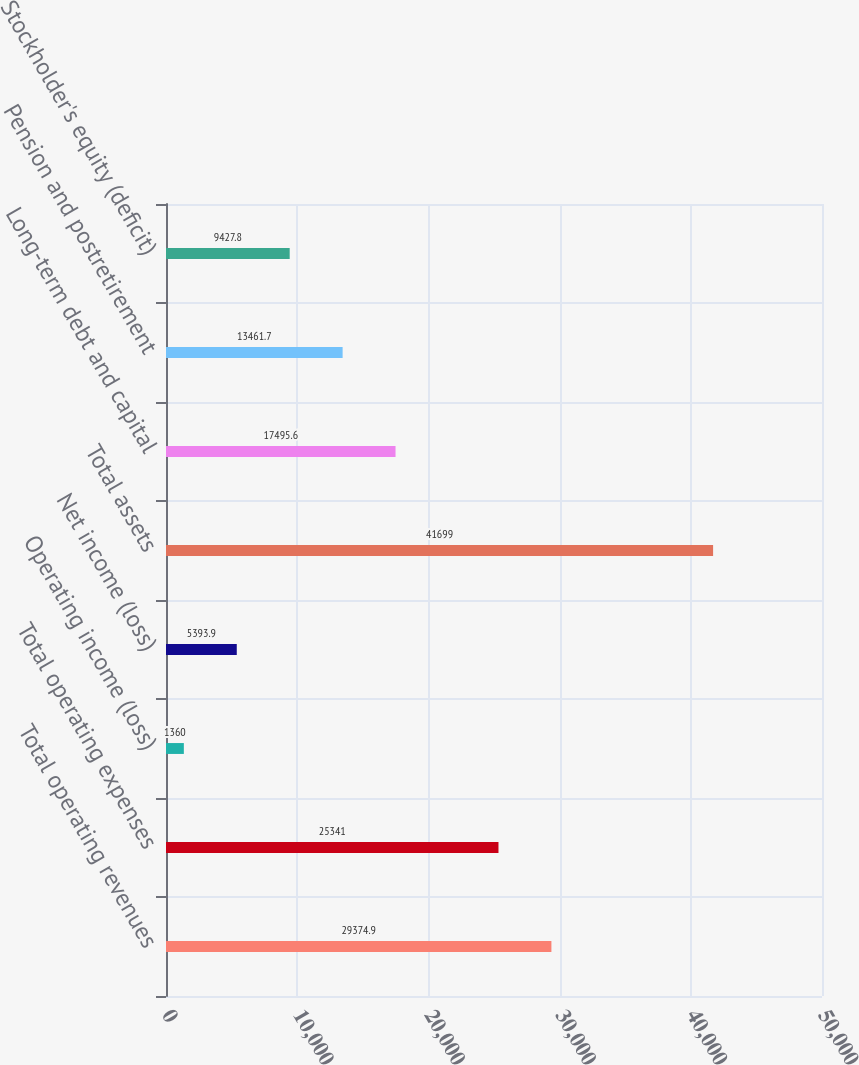<chart> <loc_0><loc_0><loc_500><loc_500><bar_chart><fcel>Total operating revenues<fcel>Total operating expenses<fcel>Operating income (loss)<fcel>Net income (loss)<fcel>Total assets<fcel>Long-term debt and capital<fcel>Pension and postretirement<fcel>Stockholder's equity (deficit)<nl><fcel>29374.9<fcel>25341<fcel>1360<fcel>5393.9<fcel>41699<fcel>17495.6<fcel>13461.7<fcel>9427.8<nl></chart> 